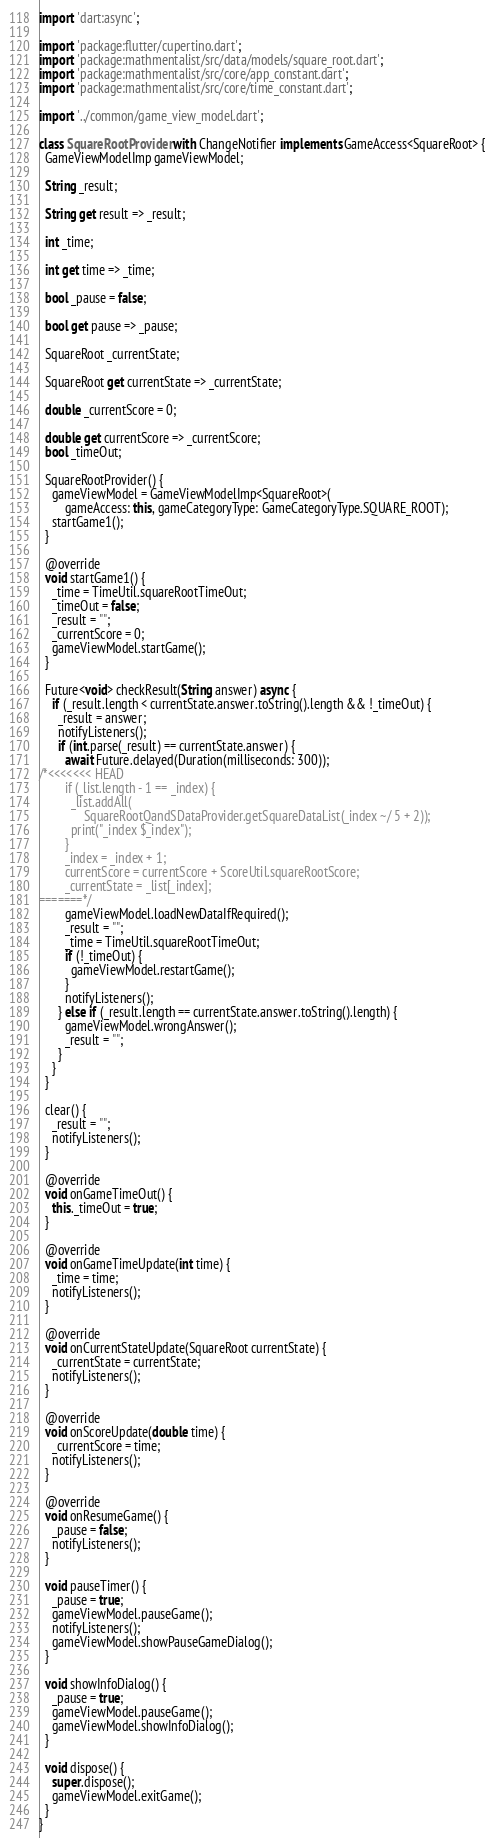Convert code to text. <code><loc_0><loc_0><loc_500><loc_500><_Dart_>import 'dart:async';

import 'package:flutter/cupertino.dart';
import 'package:mathmentalist/src/data/models/square_root.dart';
import 'package:mathmentalist/src/core/app_constant.dart';
import 'package:mathmentalist/src/core/time_constant.dart';

import '../common/game_view_model.dart';

class SquareRootProvider with ChangeNotifier implements GameAccess<SquareRoot> {
  GameViewModelImp gameViewModel;

  String _result;

  String get result => _result;

  int _time;

  int get time => _time;

  bool _pause = false;

  bool get pause => _pause;

  SquareRoot _currentState;

  SquareRoot get currentState => _currentState;

  double _currentScore = 0;

  double get currentScore => _currentScore;
  bool _timeOut;

  SquareRootProvider() {
    gameViewModel = GameViewModelImp<SquareRoot>(
        gameAccess: this, gameCategoryType: GameCategoryType.SQUARE_ROOT);
    startGame1();
  }

  @override
  void startGame1() {
    _time = TimeUtil.squareRootTimeOut;
    _timeOut = false;
    _result = "";
    _currentScore = 0;
    gameViewModel.startGame();
  }

  Future<void> checkResult(String answer) async {
    if (_result.length < currentState.answer.toString().length && !_timeOut) {
      _result = answer;
      notifyListeners();
      if (int.parse(_result) == currentState.answer) {
        await Future.delayed(Duration(milliseconds: 300));
/*<<<<<<< HEAD
        if (_list.length - 1 == _index) {
          _list.addAll(
              SquareRootQandSDataProvider.getSquareDataList(_index ~/ 5 + 2));
          print("_index $_index");
        }
        _index = _index + 1;
        currentScore = currentScore + ScoreUtil.squareRootScore;
        _currentState = _list[_index];
=======*/
        gameViewModel.loadNewDataIfRequired();
        _result = "";
        _time = TimeUtil.squareRootTimeOut;
        if (!_timeOut) {
          gameViewModel.restartGame();
        }
        notifyListeners();
      } else if (_result.length == currentState.answer.toString().length) {
        gameViewModel.wrongAnswer();
        _result = "";
      }
    }
  }

  clear() {
    _result = "";
    notifyListeners();
  }

  @override
  void onGameTimeOut() {
    this._timeOut = true;
  }

  @override
  void onGameTimeUpdate(int time) {
    _time = time;
    notifyListeners();
  }

  @override
  void onCurrentStateUpdate(SquareRoot currentState) {
    _currentState = currentState;
    notifyListeners();
  }

  @override
  void onScoreUpdate(double time) {
    _currentScore = time;
    notifyListeners();
  }

  @override
  void onResumeGame() {
    _pause = false;
    notifyListeners();
  }

  void pauseTimer() {
    _pause = true;
    gameViewModel.pauseGame();
    notifyListeners();
    gameViewModel.showPauseGameDialog();
  }

  void showInfoDialog() {
    _pause = true;
    gameViewModel.pauseGame();
    gameViewModel.showInfoDialog();
  }

  void dispose() {
    super.dispose();
    gameViewModel.exitGame();
  }
}
</code> 